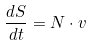<formula> <loc_0><loc_0><loc_500><loc_500>\frac { d S } { d t } = N \cdot v</formula> 